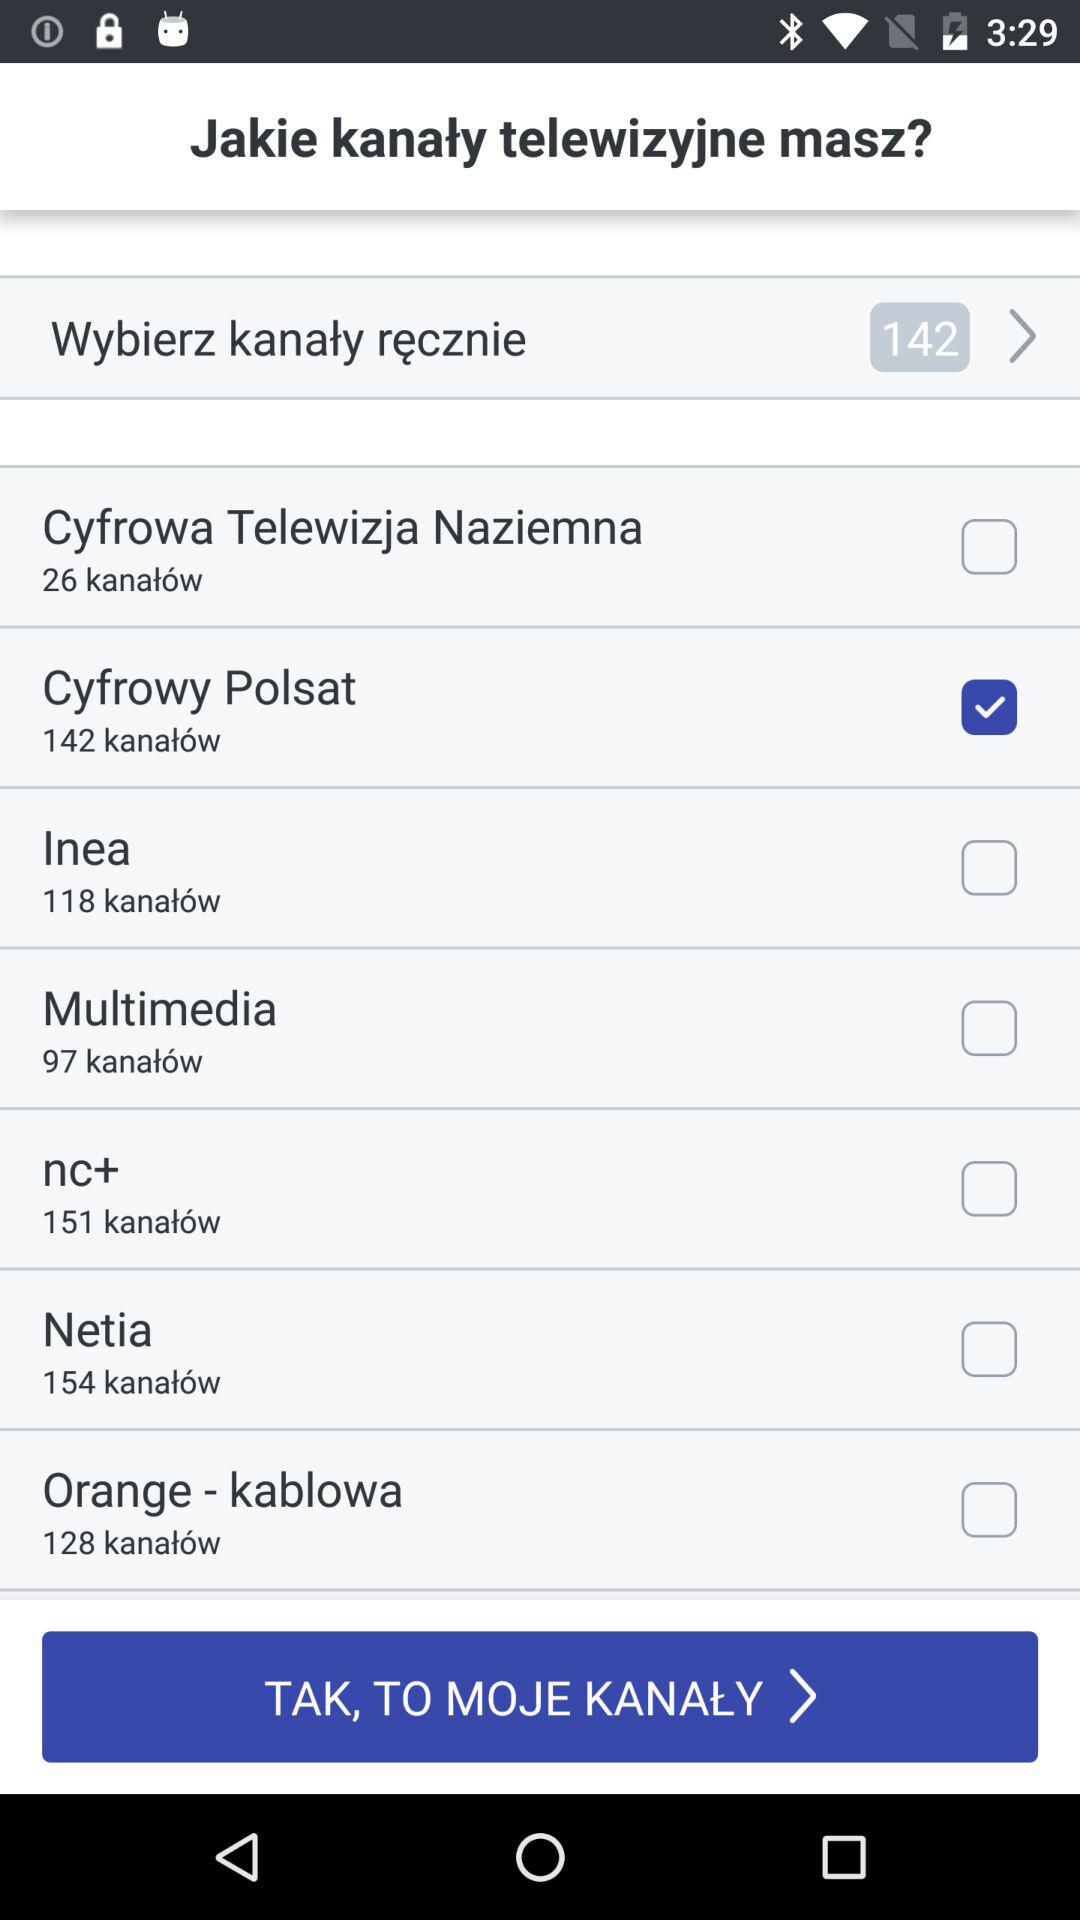Ile kanałów ma Cyfrowa Telewizja Naziemna?
Answer the question using a single word or phrase. 26 